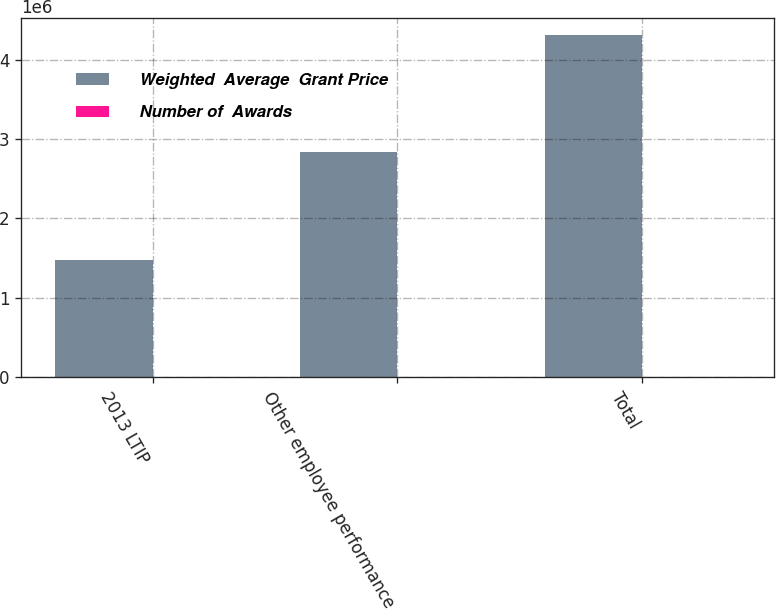Convert chart. <chart><loc_0><loc_0><loc_500><loc_500><stacked_bar_chart><ecel><fcel>2013 LTIP<fcel>Other employee performance<fcel>Total<nl><fcel>Weighted  Average  Grant Price<fcel>1.472e+06<fcel>2.84e+06<fcel>4.312e+06<nl><fcel>Number of  Awards<fcel>43.5<fcel>25.12<fcel>31.39<nl></chart> 